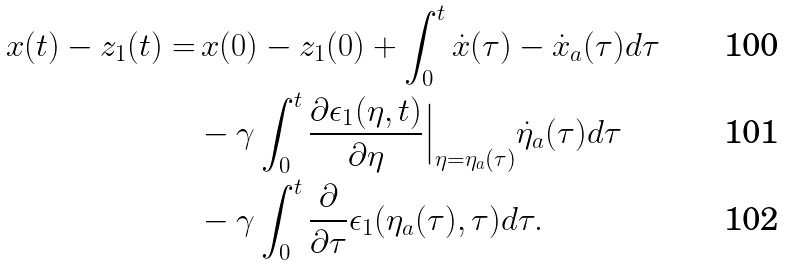<formula> <loc_0><loc_0><loc_500><loc_500>x ( t ) - z _ { 1 } ( t ) = & \, x ( 0 ) - z _ { 1 } ( 0 ) + \int _ { 0 } ^ { t } \dot { x } ( \tau ) - \dot { x } _ { a } ( \tau ) d \tau \\ & - \gamma \int _ { 0 } ^ { t } \frac { \partial \epsilon _ { 1 } ( \eta , t ) } { \partial \eta } \Big | _ { \eta = \eta _ { a } ( \tau ) } \dot { \eta } _ { a } ( \tau ) d \tau \\ & - \gamma \int _ { 0 } ^ { t } \frac { \partial } { \partial \tau } \epsilon _ { 1 } ( \eta _ { a } ( \tau ) , \tau ) d \tau .</formula> 